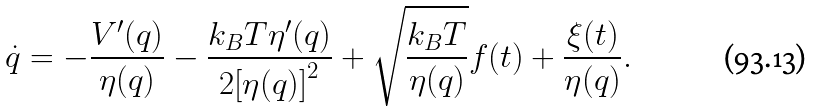<formula> <loc_0><loc_0><loc_500><loc_500>\dot { q } = { - \frac { V ^ { \prime } ( q ) } { \eta ( q ) } } - \frac { k _ { B } T { \eta ^ { \prime } } ( q ) } { 2 { [ \eta ( q ) ] } ^ { 2 } } + { \sqrt { \frac { k _ { B } T } { \eta ( q ) } } f ( t ) } + \frac { \xi ( t ) } { \eta ( q ) } .</formula> 